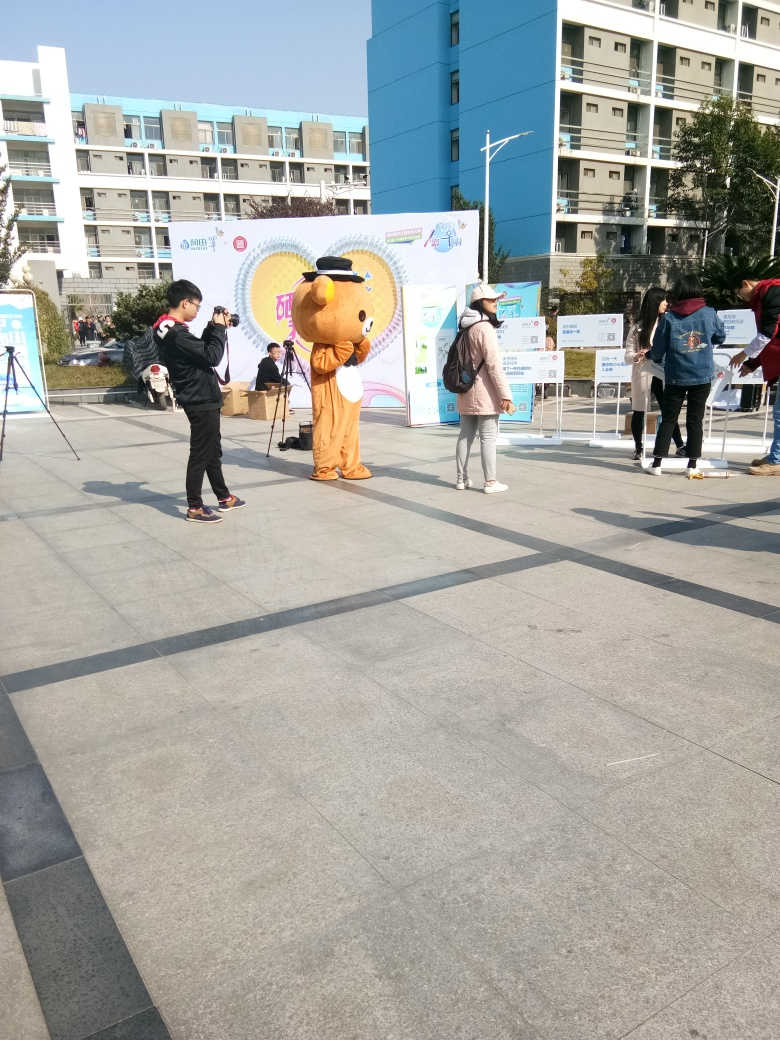Can you tell me about the mascot’s appearance? The mascot is dressed in a large, plush bear costume, complete with a cap and what appears to be a graduation gown, indicating that the event might be related to an educational theme or celebrating academic achievements. 